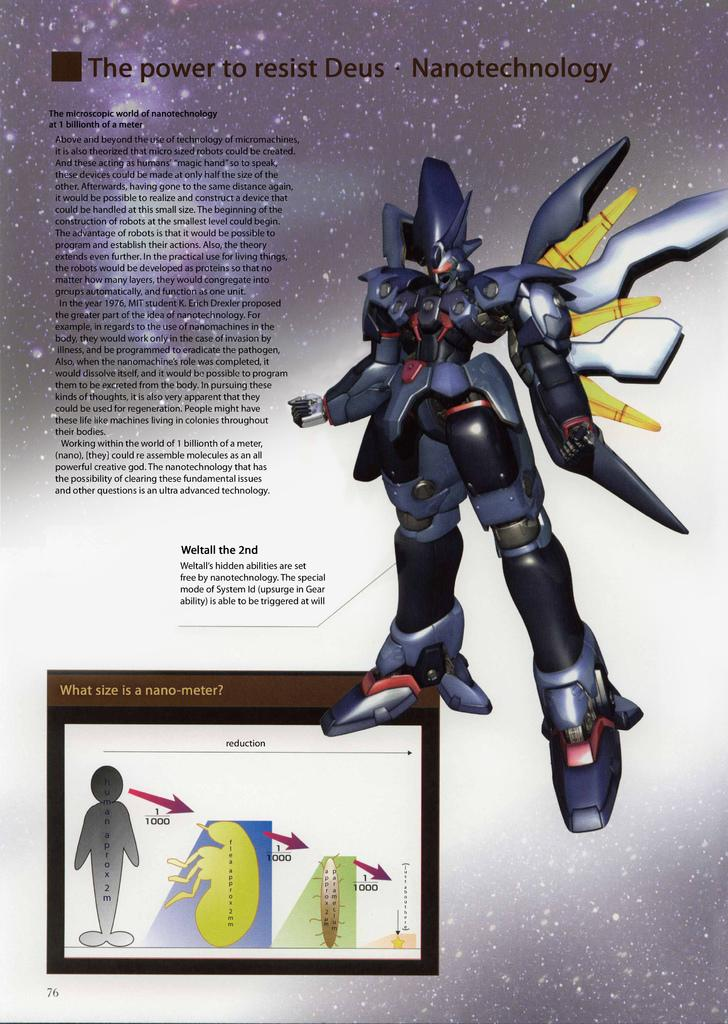<image>
Offer a succinct explanation of the picture presented. A poster that says The Power to Resist Deus. 